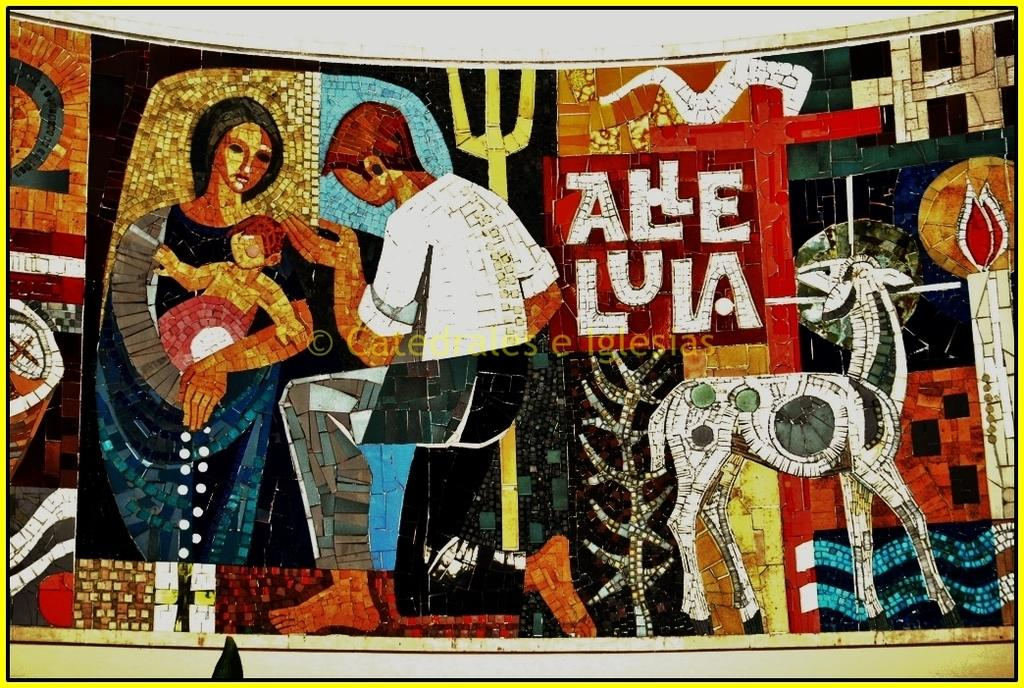What is present in the image that contains multiple images? There is a poster in the image that contains multiple images. What else can be found on the poster besides the images? There is text on the poster. How many beggars are depicted on the poster? There are no beggars depicted on the poster; it contains multiple images, but none of them are of beggars. 